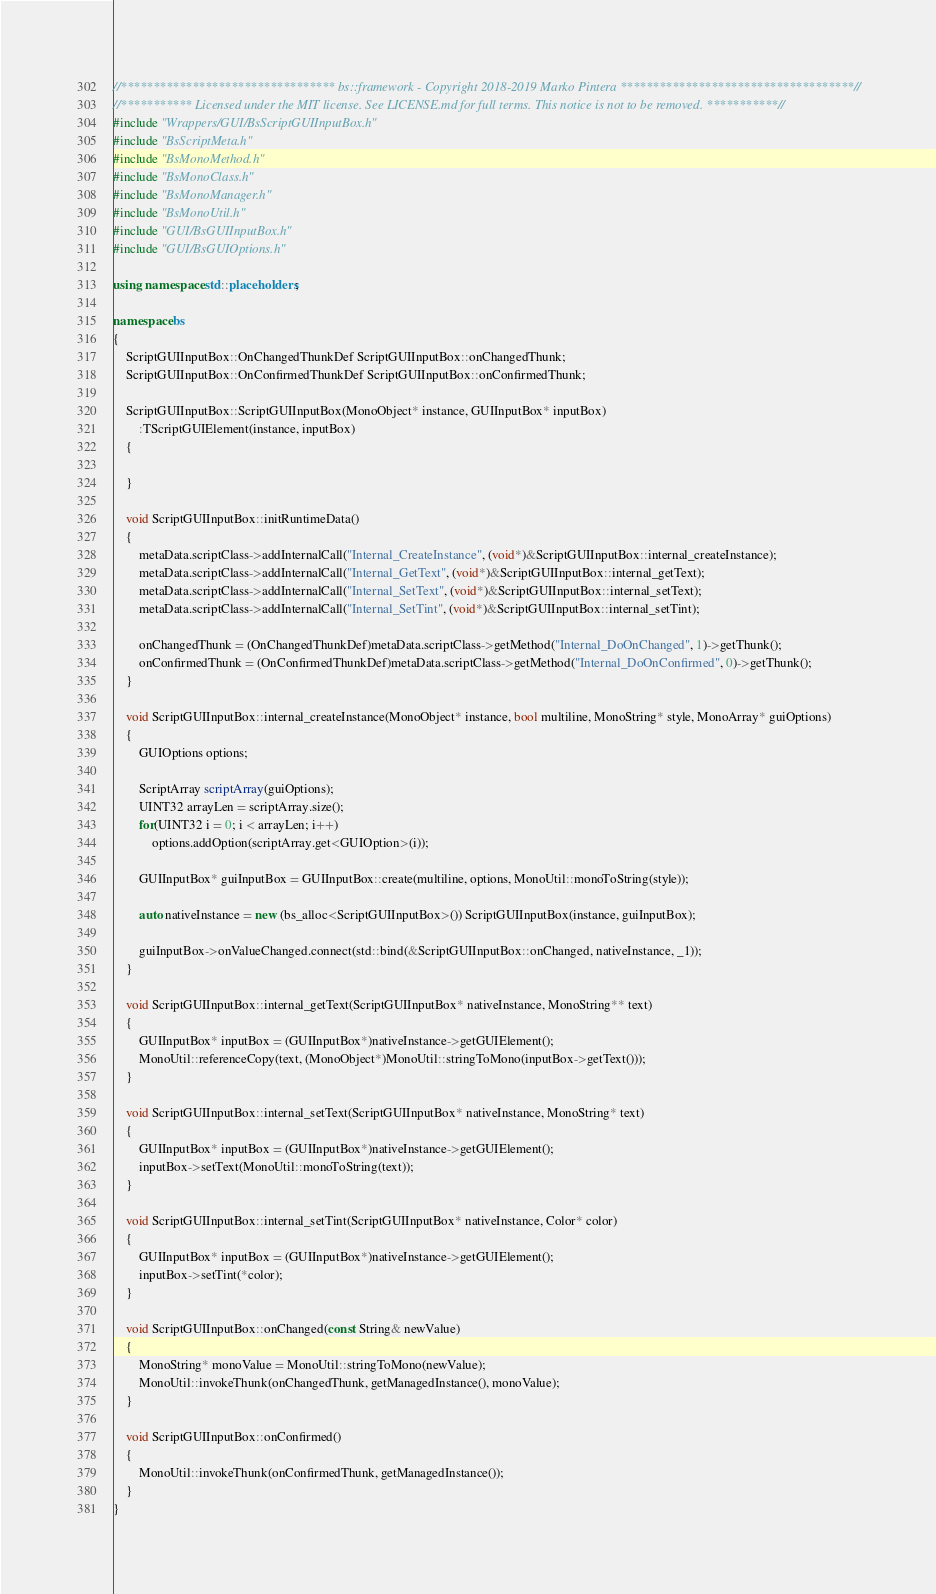Convert code to text. <code><loc_0><loc_0><loc_500><loc_500><_C++_>//********************************* bs::framework - Copyright 2018-2019 Marko Pintera ************************************//
//*********** Licensed under the MIT license. See LICENSE.md for full terms. This notice is not to be removed. ***********//
#include "Wrappers/GUI/BsScriptGUIInputBox.h"
#include "BsScriptMeta.h"
#include "BsMonoMethod.h"
#include "BsMonoClass.h"
#include "BsMonoManager.h"
#include "BsMonoUtil.h"
#include "GUI/BsGUIInputBox.h"
#include "GUI/BsGUIOptions.h"

using namespace std::placeholders;

namespace bs
{
	ScriptGUIInputBox::OnChangedThunkDef ScriptGUIInputBox::onChangedThunk;
	ScriptGUIInputBox::OnConfirmedThunkDef ScriptGUIInputBox::onConfirmedThunk;

	ScriptGUIInputBox::ScriptGUIInputBox(MonoObject* instance, GUIInputBox* inputBox)
		:TScriptGUIElement(instance, inputBox)
	{

	}

	void ScriptGUIInputBox::initRuntimeData()
	{
		metaData.scriptClass->addInternalCall("Internal_CreateInstance", (void*)&ScriptGUIInputBox::internal_createInstance);
		metaData.scriptClass->addInternalCall("Internal_GetText", (void*)&ScriptGUIInputBox::internal_getText);
		metaData.scriptClass->addInternalCall("Internal_SetText", (void*)&ScriptGUIInputBox::internal_setText);
		metaData.scriptClass->addInternalCall("Internal_SetTint", (void*)&ScriptGUIInputBox::internal_setTint);

		onChangedThunk = (OnChangedThunkDef)metaData.scriptClass->getMethod("Internal_DoOnChanged", 1)->getThunk();
		onConfirmedThunk = (OnConfirmedThunkDef)metaData.scriptClass->getMethod("Internal_DoOnConfirmed", 0)->getThunk();
	}

	void ScriptGUIInputBox::internal_createInstance(MonoObject* instance, bool multiline, MonoString* style, MonoArray* guiOptions)
	{
		GUIOptions options;

		ScriptArray scriptArray(guiOptions);
		UINT32 arrayLen = scriptArray.size();
		for(UINT32 i = 0; i < arrayLen; i++)
			options.addOption(scriptArray.get<GUIOption>(i));

		GUIInputBox* guiInputBox = GUIInputBox::create(multiline, options, MonoUtil::monoToString(style));

		auto nativeInstance = new (bs_alloc<ScriptGUIInputBox>()) ScriptGUIInputBox(instance, guiInputBox);

		guiInputBox->onValueChanged.connect(std::bind(&ScriptGUIInputBox::onChanged, nativeInstance, _1));
	}

	void ScriptGUIInputBox::internal_getText(ScriptGUIInputBox* nativeInstance, MonoString** text)
	{
		GUIInputBox* inputBox = (GUIInputBox*)nativeInstance->getGUIElement();
		MonoUtil::referenceCopy(text, (MonoObject*)MonoUtil::stringToMono(inputBox->getText()));
	}

	void ScriptGUIInputBox::internal_setText(ScriptGUIInputBox* nativeInstance, MonoString* text)
	{
		GUIInputBox* inputBox = (GUIInputBox*)nativeInstance->getGUIElement();
		inputBox->setText(MonoUtil::monoToString(text));
	}

	void ScriptGUIInputBox::internal_setTint(ScriptGUIInputBox* nativeInstance, Color* color)
	{
		GUIInputBox* inputBox = (GUIInputBox*)nativeInstance->getGUIElement();
		inputBox->setTint(*color);
	}

	void ScriptGUIInputBox::onChanged(const String& newValue)
	{
		MonoString* monoValue = MonoUtil::stringToMono(newValue);
		MonoUtil::invokeThunk(onChangedThunk, getManagedInstance(), monoValue);
	}

	void ScriptGUIInputBox::onConfirmed()
	{
		MonoUtil::invokeThunk(onConfirmedThunk, getManagedInstance());
	}
}</code> 